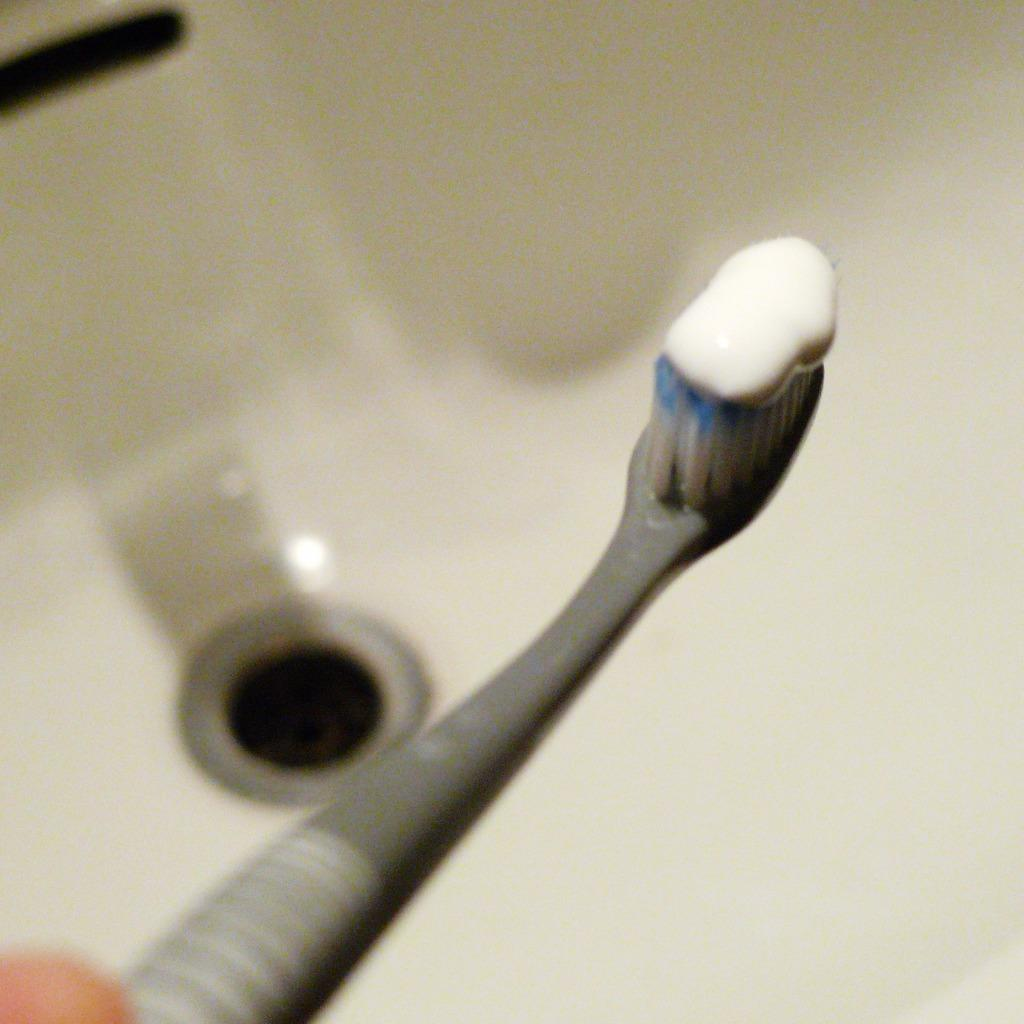What object is present in the image that is used for dental hygiene? There is a toothbrush in the image. What substance is on the toothbrush? The toothbrush has toothpaste on it. What can be seen in the background of the image? There is a white sink in the background of the image. What feature does the sink have? The sink has a sinkhole. What type of plant is growing in the sinkhole in the image? There is no plant growing in the sinkhole in the image; it is a feature of the sink and not a location for plant growth. 